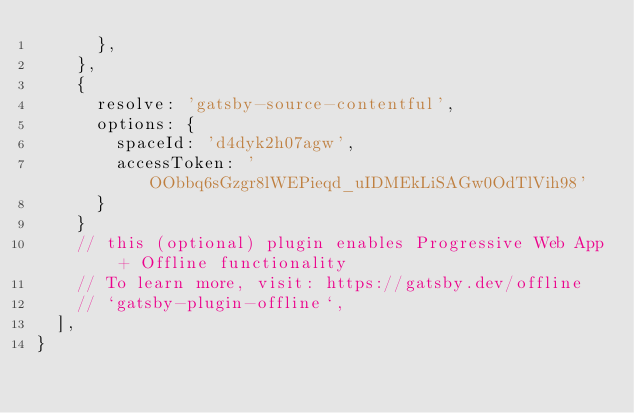Convert code to text. <code><loc_0><loc_0><loc_500><loc_500><_JavaScript_>      },
    },
    {
      resolve: 'gatsby-source-contentful',
      options: {
        spaceId: 'd4dyk2h07agw',
        accessToken: 'OObbq6sGzgr8lWEPieqd_uIDMEkLiSAGw0OdTlVih98'
      }
    }
    // this (optional) plugin enables Progressive Web App + Offline functionality
    // To learn more, visit: https://gatsby.dev/offline
    // `gatsby-plugin-offline`,
  ],
}
</code> 